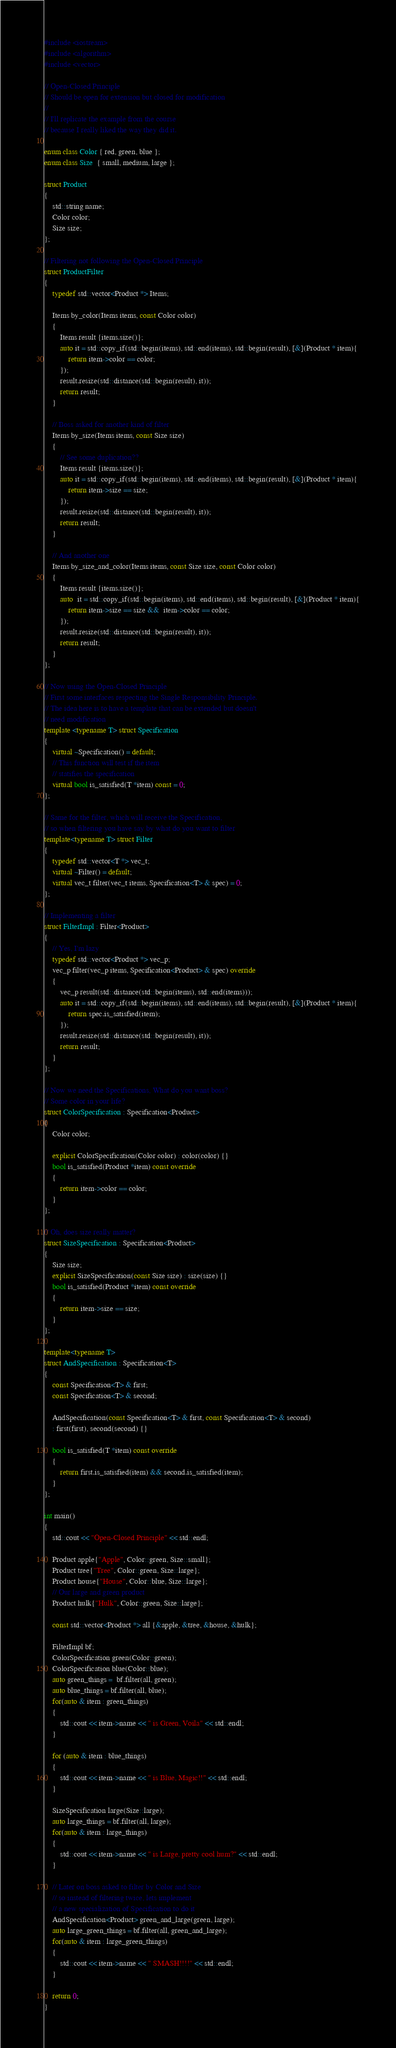Convert code to text. <code><loc_0><loc_0><loc_500><loc_500><_C++_>#include <iostream>
#include <algorithm>
#include <vector>

// Open-Closed Principle
// Should be open for extension but closed for modification
//
// I'll replicate the example from the course
// because I really liked the way they did it.

enum class Color { red, green, blue };
enum class Size  { small, medium, large };

struct Product
{
    std::string name;
    Color color;
    Size size;
};

// Filtering not following the Open-Closed Principle
struct ProductFilter
{
    typedef std::vector<Product *> Items;

    Items by_color(Items items, const Color color)
    {
        Items result {items.size()};
        auto it = std::copy_if(std::begin(items), std::end(items), std::begin(result), [&](Product * item){
            return item->color == color;
        });
        result.resize(std::distance(std::begin(result), it));
        return result;
    }

    // Boss asked for another kind of filter
    Items by_size(Items items, const Size size)
    {
        // See some duplication??
        Items result {items.size()};
        auto it = std::copy_if(std::begin(items), std::end(items), std::begin(result), [&](Product * item){
            return item->size == size;
        });
        result.resize(std::distance(std::begin(result), it));
        return result;
    }

    // And another one
    Items by_size_and_color(Items items, const Size size, const Color color)
    {
        Items result {items.size()};
        auto  it = std::copy_if(std::begin(items), std::end(items), std::begin(result), [&](Product * item){
            return item->size == size &&  item->color == color;
        });
        result.resize(std::distance(std::begin(result), it));
        return result;
    }
};

// Now using the Open-Closed Principle
// First some interfaces respecting the Single Responsibility Principle.
// The idea here is to have a template that can be extended but doesn't
// need modification
template <typename T> struct Specification
{
    virtual ~Specification() = default;
    // This function will test if the item
    // statifies the specification
    virtual bool is_satisfied(T *item) const = 0;
};

// Same for the filter, which will receive the Specification,
// so when filtering you have say by what do you want to filter
template<typename T> struct Filter
{
    typedef std::vector<T *> vec_t;
    virtual ~Filter() = default;
    virtual vec_t filter(vec_t items, Specification<T> & spec) = 0;
};

// Implementing a filter
struct FilterImpl : Filter<Product>
{
    // Yes, I'm lazy
    typedef std::vector<Product *> vec_p;
    vec_p filter(vec_p items, Specification<Product> & spec) override
    {
        vec_p result(std::distance(std::begin(items), std::end(items)));
        auto it = std::copy_if(std::begin(items), std::end(items), std::begin(result), [&](Product * item){
            return spec.is_satisfied(item);
        });
        result.resize(std::distance(std::begin(result), it));
        return result;
    }
};

// Now we need the Specifications, What do you want boss?
// Some color in your life?
struct ColorSpecification : Specification<Product>
{
    Color color;

    explicit ColorSpecification(Color color) : color(color) {}
    bool is_satisfied(Product *item) const override
    {
        return item->color == color;
    }
};

// Oh, does size really matter?
struct SizeSpecification : Specification<Product>
{
    Size size;
    explicit SizeSpecification(const Size size) : size(size) {}
    bool is_satisfied(Product *item) const override
    {
        return item->size == size;
    }
};

template<typename T>
struct AndSpecification : Specification<T>
{
    const Specification<T> & first;
    const Specification<T> & second;

    AndSpecification(const Specification<T> & first, const Specification<T> & second)
    : first(first), second(second) {}

    bool is_satisfied(T *item) const override
    {
        return first.is_satisfied(item) && second.is_satisfied(item);
    }
};

int main()
{
    std::cout << "Open-Closed Principle" << std::endl;

    Product apple{"Apple", Color::green, Size::small};
    Product tree{"Tree", Color::green, Size::large};
    Product house{"House", Color::blue, Size::large};
    // Our large and green product
    Product hulk{"Hulk", Color::green, Size::large};

    const std::vector<Product *> all {&apple, &tree, &house, &hulk};

    FilterImpl bf;
    ColorSpecification green(Color::green);
    ColorSpecification blue(Color::blue);
    auto green_things =  bf.filter(all, green);
    auto blue_things = bf.filter(all, blue);
    for(auto & item : green_things)
    {
        std::cout << item->name << " is Green, Voila" << std::endl;
    }

    for (auto & item : blue_things)
    {
        std::cout << item->name << " is Blue, Magic!!" << std::endl;
    }

    SizeSpecification large(Size::large);
    auto large_things = bf.filter(all, large);
    for(auto & item : large_things)
    {
        std::cout << item->name << " is Large, pretty cool hum?" << std::endl;
    }

    // Later on boss asked to filter by Color and Size
    // so instead of filtering twice, lets implement
    // a new specialization of Specification to do it
    AndSpecification<Product> green_and_large(green, large);
    auto large_green_things = bf.filter(all, green_and_large);
    for(auto & item : large_green_things)
    {
        std::cout << item->name << " SMASH!!!!" << std::endl;
    }

    return 0;
}
</code> 